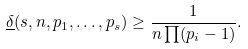<formula> <loc_0><loc_0><loc_500><loc_500>\underline { \delta } ( s , n , p _ { 1 } , \dots , p _ { s } ) \geq \frac { 1 } { n \prod ( p _ { i } - 1 ) } .</formula> 